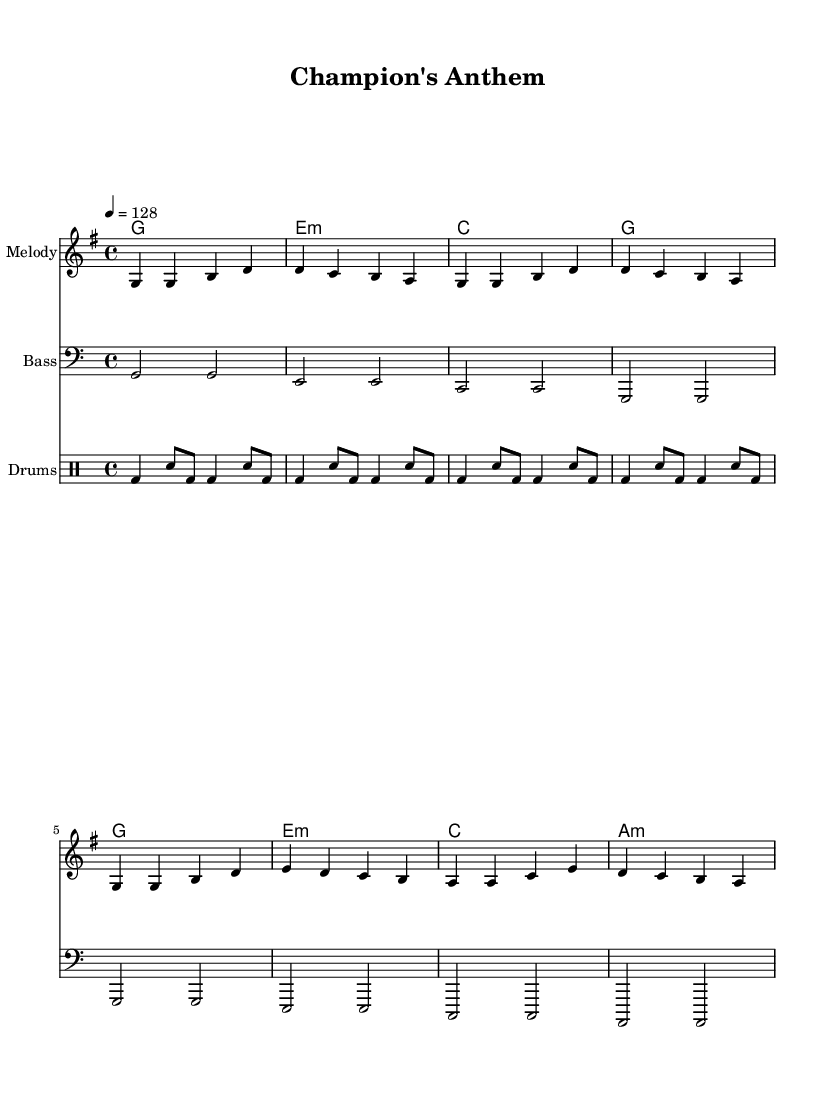What is the key signature of this music? The key signature is G major, which has one sharp (F#). You can identify the key signature by looking at the left side of the staff, where the sharp is placed.
Answer: G major What is the time signature of this music? The time signature is 4/4, which indicates there are four beats per measure, and the quarter note gets one beat. This can be seen at the beginning of the score after the key signature.
Answer: 4/4 What is the tempo marking for this piece? The tempo marking is 128 beats per minute. It is indicated by the notation "4 = 128," which means that the quarter note is set to 128 beats per minute.
Answer: 128 How many measures are in the melody? The melody consists of 8 measures. By counting the groups of notes divided by vertical lines (bar lines) in the melody staff, you can see there are 8 distinct measures.
Answer: 8 What is the first note of the melody? The first note of the melody is G. It is found at the beginning of the staff notation, which starts with G in the treble clef.
Answer: G Which chord is played in the third measure? The chord played in the third measure is C major. By looking at the harmonic staff, you can see the chord symbols written above the measure, and the third measure shows a "C" chord symbol.
Answer: C major What type of rhythm does the drum part primarily use? The drum part primarily uses a combination of bass drum and snare drum patterns. The notation indicates various arrangements of bass (bd) and snare (sn) notes, showing a steady rhythm throughout.
Answer: Bass and snare 